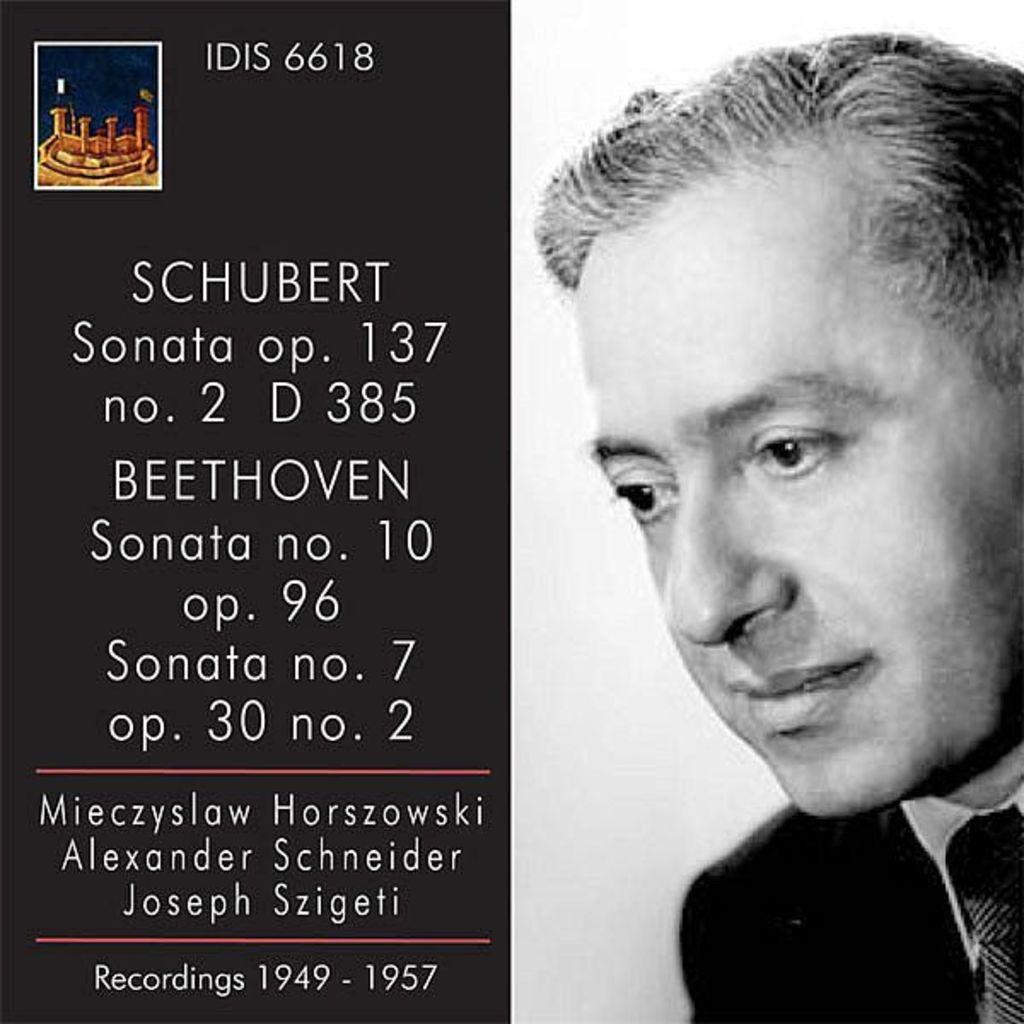What type of visual is the image? The image is a poster. Where is the text located on the poster? The text is on the left side of the poster. What is depicted on the right side of the poster? There is a face of a person on the right side of the poster. What type of jelly can be seen in the poster? There is no jelly present in the poster. What is the person's desire in the poster? The poster does not indicate any specific desires of the person depicted. 